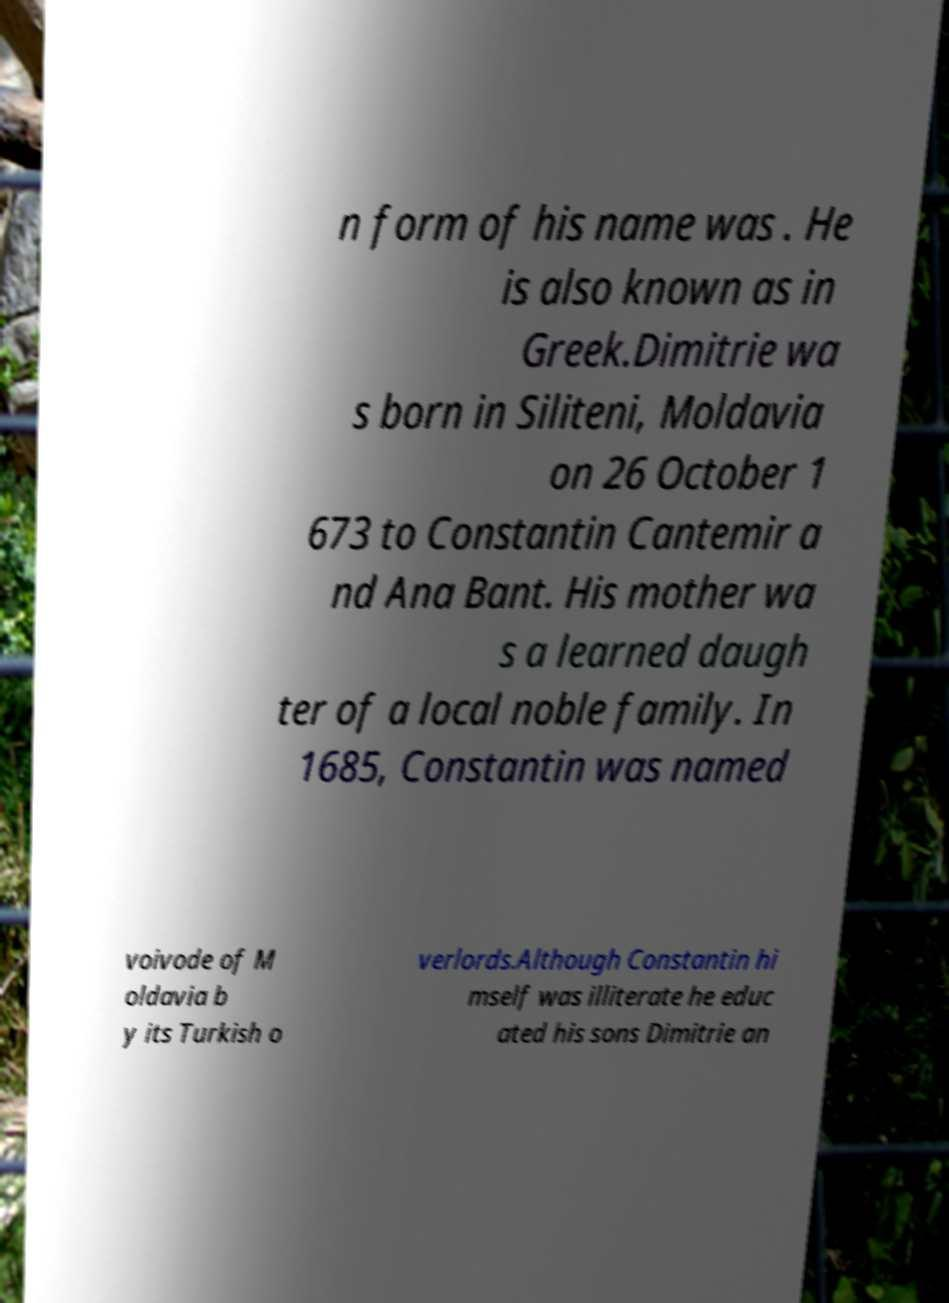Please read and relay the text visible in this image. What does it say? n form of his name was . He is also known as in Greek.Dimitrie wa s born in Siliteni, Moldavia on 26 October 1 673 to Constantin Cantemir a nd Ana Bant. His mother wa s a learned daugh ter of a local noble family. In 1685, Constantin was named voivode of M oldavia b y its Turkish o verlords.Although Constantin hi mself was illiterate he educ ated his sons Dimitrie an 